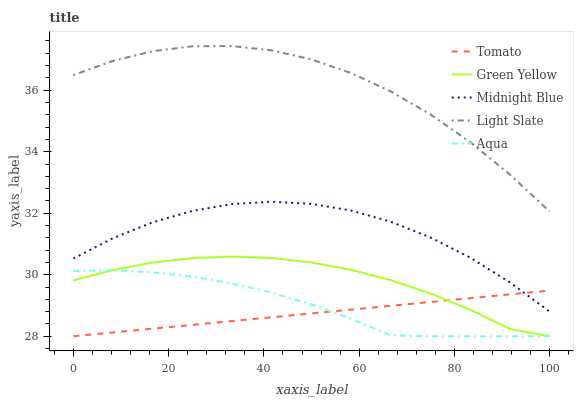Does Tomato have the minimum area under the curve?
Answer yes or no. Yes. Does Light Slate have the maximum area under the curve?
Answer yes or no. Yes. Does Green Yellow have the minimum area under the curve?
Answer yes or no. No. Does Green Yellow have the maximum area under the curve?
Answer yes or no. No. Is Tomato the smoothest?
Answer yes or no. Yes. Is Light Slate the roughest?
Answer yes or no. Yes. Is Green Yellow the smoothest?
Answer yes or no. No. Is Green Yellow the roughest?
Answer yes or no. No. Does Tomato have the lowest value?
Answer yes or no. Yes. Does Light Slate have the lowest value?
Answer yes or no. No. Does Light Slate have the highest value?
Answer yes or no. Yes. Does Green Yellow have the highest value?
Answer yes or no. No. Is Green Yellow less than Midnight Blue?
Answer yes or no. Yes. Is Midnight Blue greater than Aqua?
Answer yes or no. Yes. Does Aqua intersect Tomato?
Answer yes or no. Yes. Is Aqua less than Tomato?
Answer yes or no. No. Is Aqua greater than Tomato?
Answer yes or no. No. Does Green Yellow intersect Midnight Blue?
Answer yes or no. No. 